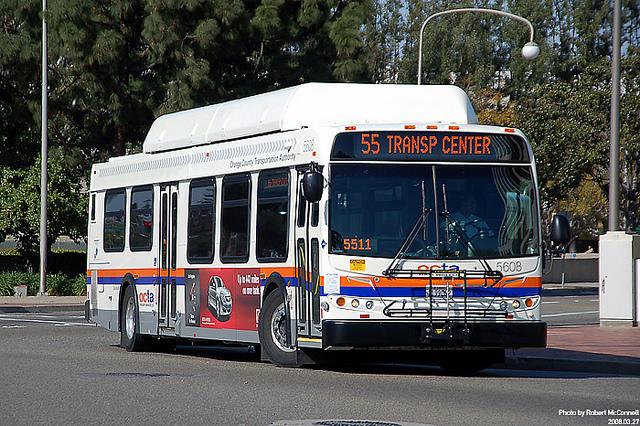Is this a new bus?
Quick response, please. Yes. Is this a new looking bus?
Short answer required. Yes. What number bus is this?
Answer briefly. 55. What is the number on the bus?
Quick response, please. 55. What is the number on the front of the bus?
Give a very brief answer. 5511. Can a person live on this bus?
Answer briefly. No. Is this bus made to be driven in the United States?
Be succinct. Yes. What number bus route is this?
Give a very brief answer. 55. Where is the bus going?
Keep it brief. Transp center. How much does this shuttle cost?
Answer briefly. $1. Is this an American bus?
Keep it brief. Yes. How many windows are on one side of the bus?
Write a very short answer. 5. What word is on the front of the bus?
Keep it brief. Transp center. How many street lights are there?
Concise answer only. 1. Is this a tour bus?
Answer briefly. No. Is the door to the bus open?
Short answer required. No. Is this a public bus?
Answer briefly. Yes. What color is the bus?
Keep it brief. White. When was the bus made?
Short answer required. 1990. What words are on the front top of the bus?
Be succinct. Transp center. Do you see number 23 on the bus?
Give a very brief answer. No. What number is on the top right of the bus?
Concise answer only. 55. What does the advertisement on the side of the bus say?
Concise answer only. Lexus. What route number is the bus currently driving?
Answer briefly. 55. 